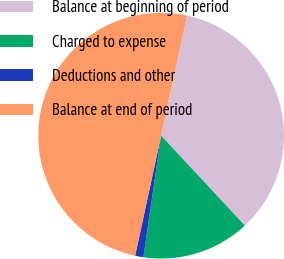Convert chart to OTSL. <chart><loc_0><loc_0><loc_500><loc_500><pie_chart><fcel>Balance at beginning of period<fcel>Charged to expense<fcel>Deductions and other<fcel>Balance at end of period<nl><fcel>34.67%<fcel>14.24%<fcel>1.09%<fcel>50.0%<nl></chart> 